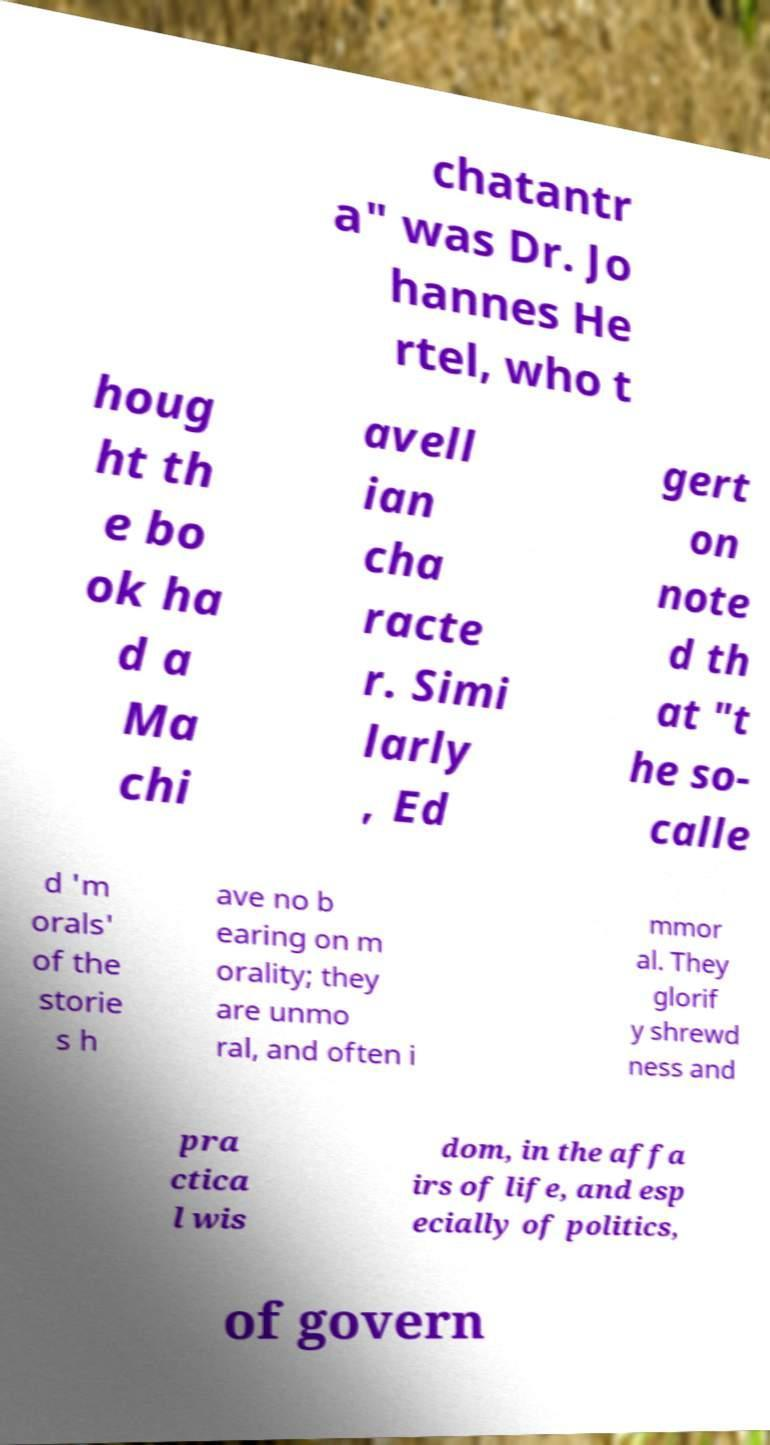What messages or text are displayed in this image? I need them in a readable, typed format. chatantr a" was Dr. Jo hannes He rtel, who t houg ht th e bo ok ha d a Ma chi avell ian cha racte r. Simi larly , Ed gert on note d th at "t he so- calle d 'm orals' of the storie s h ave no b earing on m orality; they are unmo ral, and often i mmor al. They glorif y shrewd ness and pra ctica l wis dom, in the affa irs of life, and esp ecially of politics, of govern 